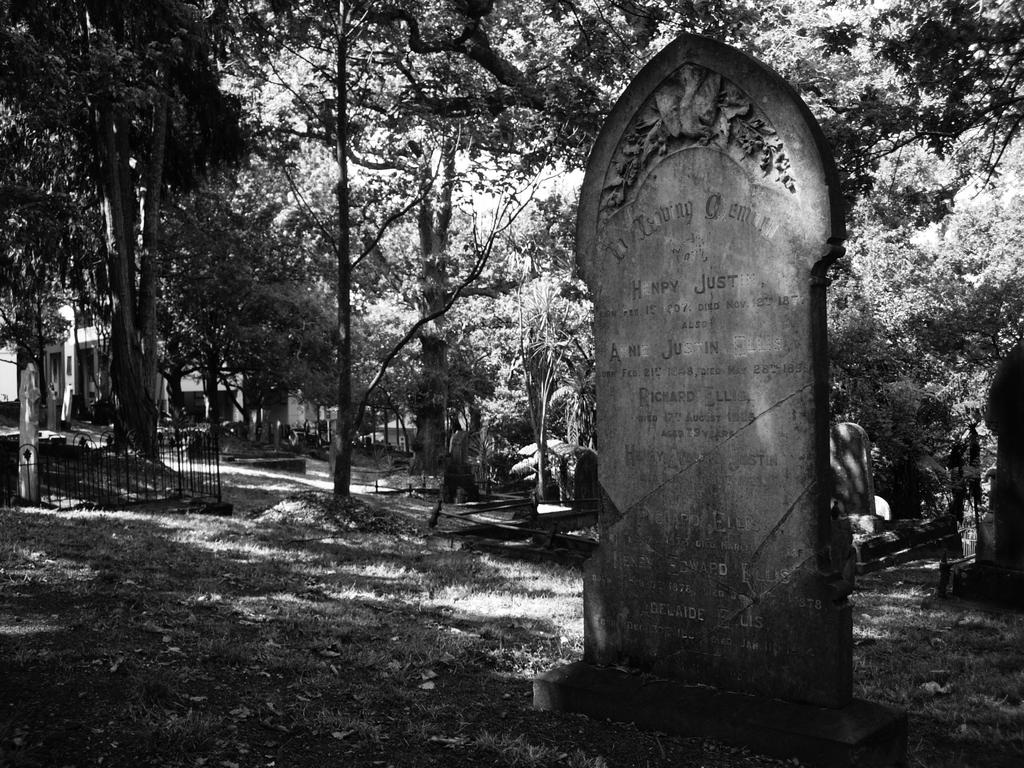What is the main object in the image? There is a memorial stone in the image. What type of natural environment is visible in the image? There is grass in the image. What type of structure is present in the image? There is a fence in the image. What type of building is visible in the image? There is a house in the image. What type of vegetation is present in the image? There are trees in the image. What language is being spoken in the discussion happening near the memorial stone? There is no discussion happening near the memorial stone in the image, so it is not possible to determine what language might be spoken. 